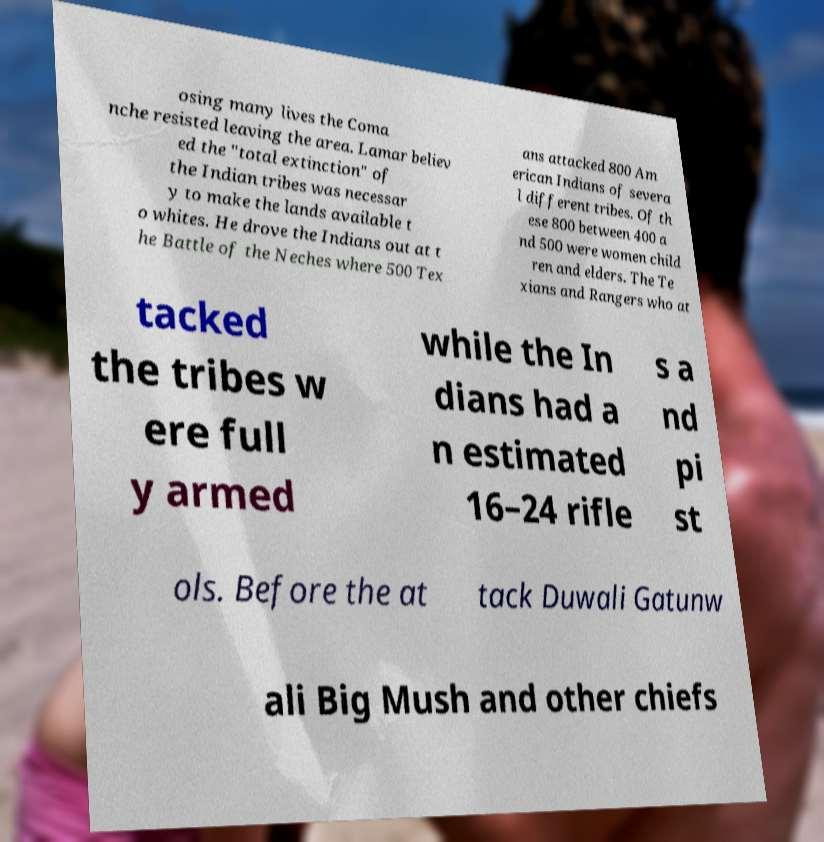Please read and relay the text visible in this image. What does it say? osing many lives the Coma nche resisted leaving the area. Lamar believ ed the "total extinction" of the Indian tribes was necessar y to make the lands available t o whites. He drove the Indians out at t he Battle of the Neches where 500 Tex ans attacked 800 Am erican Indians of severa l different tribes. Of th ese 800 between 400 a nd 500 were women child ren and elders. The Te xians and Rangers who at tacked the tribes w ere full y armed while the In dians had a n estimated 16–24 rifle s a nd pi st ols. Before the at tack Duwali Gatunw ali Big Mush and other chiefs 